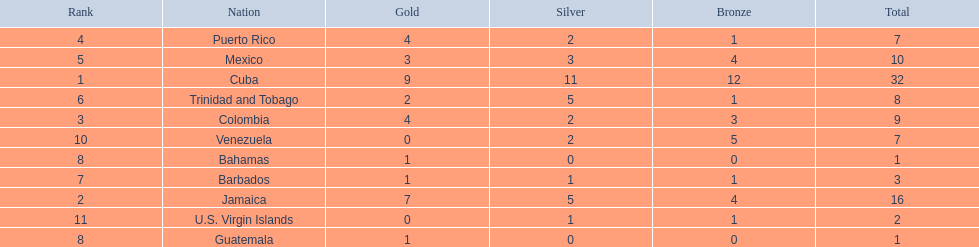What teams had four gold medals? Colombia, Puerto Rico. Of these two, which team only had one bronze medal? Puerto Rico. 